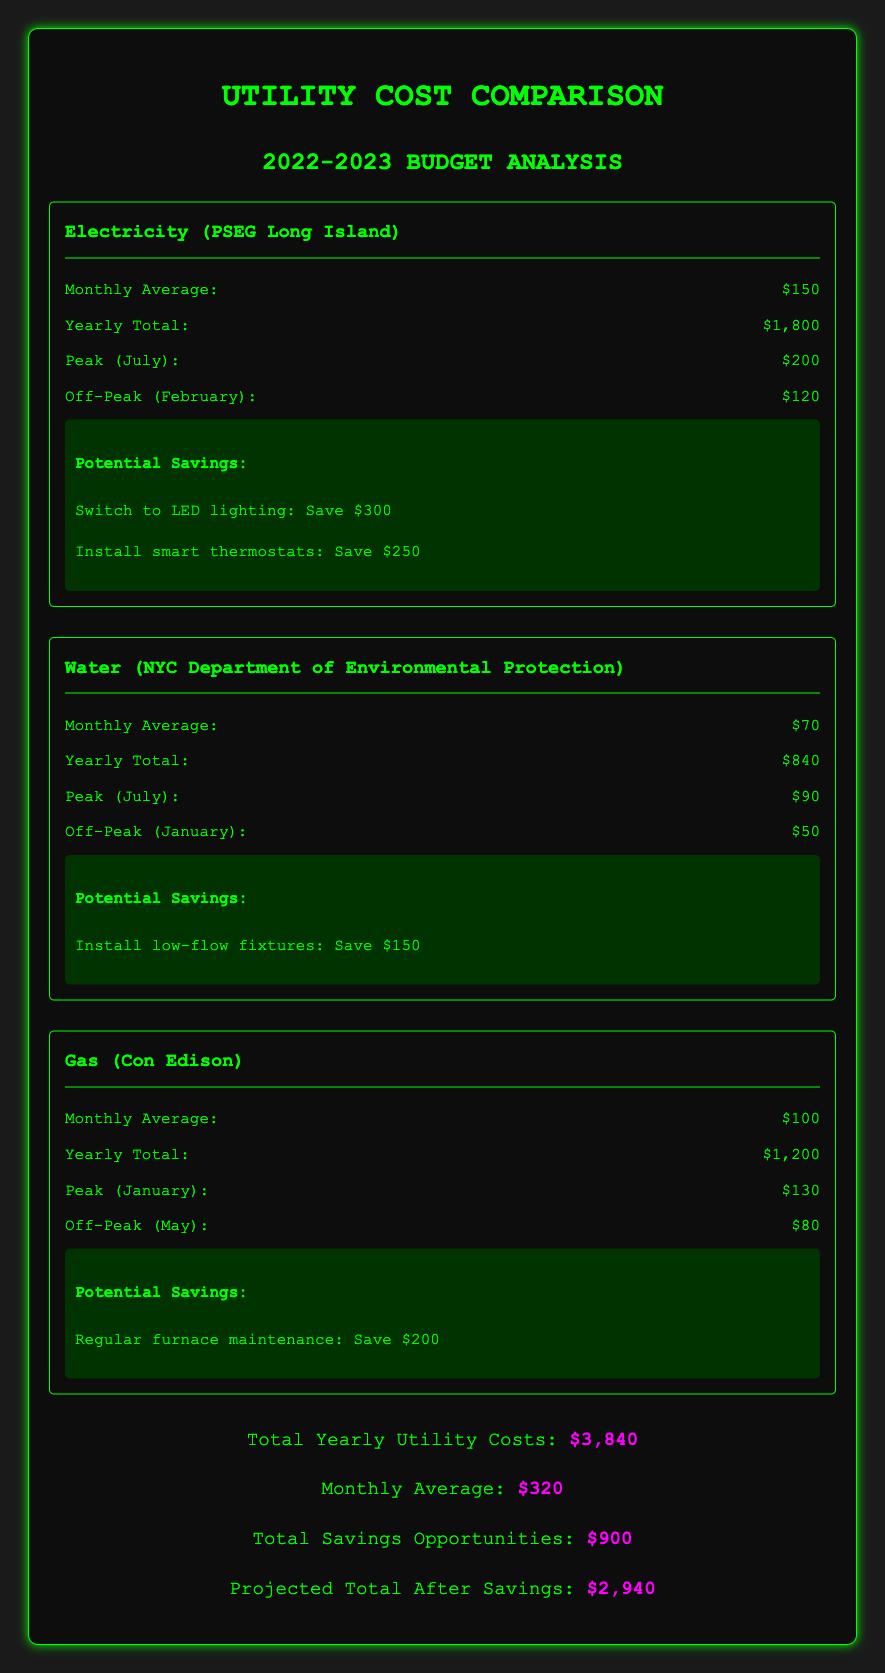What is the total yearly utility cost? The total yearly utility costs are listed in the document, which aggregates the costs of electricity, water, and gas.
Answer: $3,840 What is the potential saving for installing LED lighting? The savings from switching to LED lighting is specified under the electricity section.
Answer: $300 What is the monthly average cost of water? The document provides the monthly average cost of water, which is noted directly in the breakdown.
Answer: $70 What was the peak gas cost month? The document identifies the peak cost month for gas along with the respective cost.
Answer: January What is the projected total after applying savings? The projected total after applying identified savings is calculated in the total section of the document.
Answer: $2,940 What are the potential savings from low-flow fixtures? The document outlines specific savings opportunities, including low-flow fixtures for water.
Answer: $150 What utility had a peak cost of $200? The peak cost is detailed in the electricity section, identifying the utility and corresponding month.
Answer: Electricity What is the yearly total cost of water? The total cost of water for the year is provided in the document breakdown.
Answer: $840 What is the average monthly cost of utilities? The average monthly cost of utilities is mentioned in the totals section of the document.
Answer: $320 